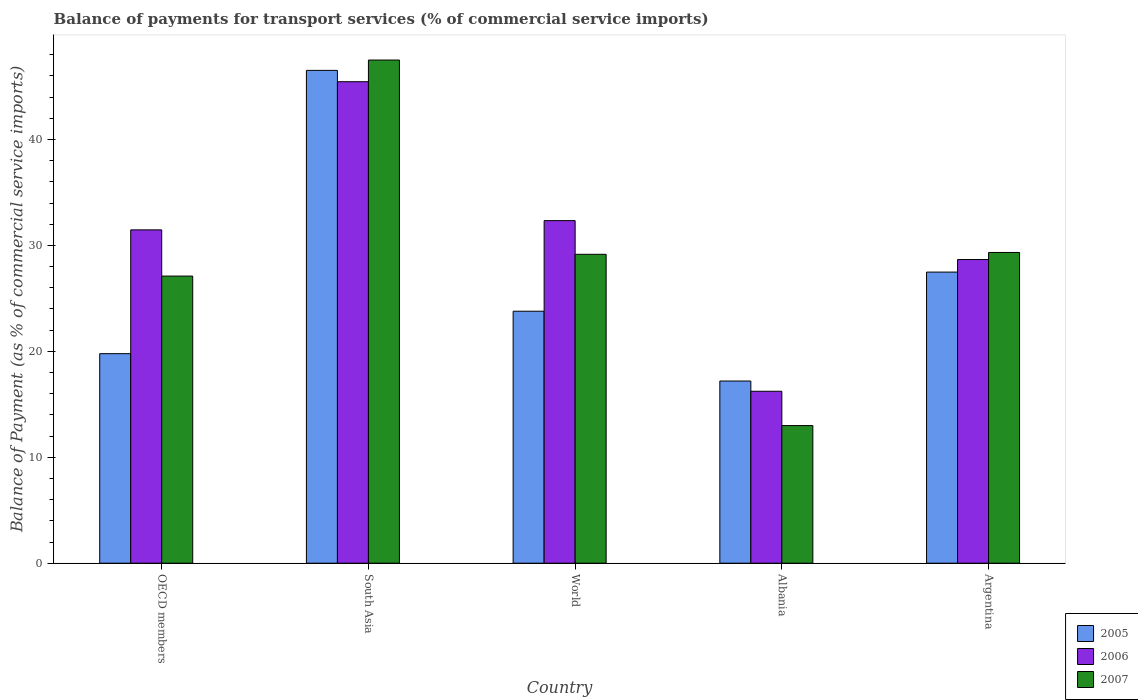How many groups of bars are there?
Your response must be concise. 5. Are the number of bars on each tick of the X-axis equal?
Your answer should be compact. Yes. What is the label of the 4th group of bars from the left?
Ensure brevity in your answer.  Albania. What is the balance of payments for transport services in 2005 in World?
Give a very brief answer. 23.79. Across all countries, what is the maximum balance of payments for transport services in 2007?
Offer a terse response. 47.5. Across all countries, what is the minimum balance of payments for transport services in 2005?
Keep it short and to the point. 17.2. In which country was the balance of payments for transport services in 2007 maximum?
Offer a terse response. South Asia. In which country was the balance of payments for transport services in 2007 minimum?
Your answer should be compact. Albania. What is the total balance of payments for transport services in 2006 in the graph?
Your answer should be very brief. 154.16. What is the difference between the balance of payments for transport services in 2005 in OECD members and that in World?
Keep it short and to the point. -4.01. What is the difference between the balance of payments for transport services in 2005 in OECD members and the balance of payments for transport services in 2006 in Argentina?
Your response must be concise. -8.88. What is the average balance of payments for transport services in 2006 per country?
Provide a succinct answer. 30.83. What is the difference between the balance of payments for transport services of/in 2007 and balance of payments for transport services of/in 2005 in South Asia?
Keep it short and to the point. 0.98. What is the ratio of the balance of payments for transport services in 2007 in Albania to that in OECD members?
Provide a succinct answer. 0.48. Is the balance of payments for transport services in 2006 in OECD members less than that in South Asia?
Your answer should be very brief. Yes. Is the difference between the balance of payments for transport services in 2007 in Albania and World greater than the difference between the balance of payments for transport services in 2005 in Albania and World?
Provide a short and direct response. No. What is the difference between the highest and the second highest balance of payments for transport services in 2005?
Give a very brief answer. -19.04. What is the difference between the highest and the lowest balance of payments for transport services in 2007?
Provide a short and direct response. 34.51. Is the sum of the balance of payments for transport services in 2006 in OECD members and South Asia greater than the maximum balance of payments for transport services in 2005 across all countries?
Your answer should be very brief. Yes. How many bars are there?
Your response must be concise. 15. What is the difference between two consecutive major ticks on the Y-axis?
Offer a very short reply. 10. How are the legend labels stacked?
Your response must be concise. Vertical. What is the title of the graph?
Make the answer very short. Balance of payments for transport services (% of commercial service imports). Does "2014" appear as one of the legend labels in the graph?
Offer a terse response. No. What is the label or title of the X-axis?
Offer a terse response. Country. What is the label or title of the Y-axis?
Offer a very short reply. Balance of Payment (as % of commercial service imports). What is the Balance of Payment (as % of commercial service imports) of 2005 in OECD members?
Make the answer very short. 19.78. What is the Balance of Payment (as % of commercial service imports) in 2006 in OECD members?
Your response must be concise. 31.47. What is the Balance of Payment (as % of commercial service imports) in 2007 in OECD members?
Ensure brevity in your answer.  27.11. What is the Balance of Payment (as % of commercial service imports) of 2005 in South Asia?
Give a very brief answer. 46.53. What is the Balance of Payment (as % of commercial service imports) in 2006 in South Asia?
Provide a succinct answer. 45.46. What is the Balance of Payment (as % of commercial service imports) in 2007 in South Asia?
Your answer should be compact. 47.5. What is the Balance of Payment (as % of commercial service imports) of 2005 in World?
Provide a succinct answer. 23.79. What is the Balance of Payment (as % of commercial service imports) of 2006 in World?
Offer a very short reply. 32.34. What is the Balance of Payment (as % of commercial service imports) of 2007 in World?
Your answer should be very brief. 29.16. What is the Balance of Payment (as % of commercial service imports) of 2005 in Albania?
Offer a terse response. 17.2. What is the Balance of Payment (as % of commercial service imports) of 2006 in Albania?
Your answer should be compact. 16.23. What is the Balance of Payment (as % of commercial service imports) of 2007 in Albania?
Offer a terse response. 12.99. What is the Balance of Payment (as % of commercial service imports) in 2005 in Argentina?
Offer a terse response. 27.48. What is the Balance of Payment (as % of commercial service imports) in 2006 in Argentina?
Keep it short and to the point. 28.67. What is the Balance of Payment (as % of commercial service imports) of 2007 in Argentina?
Your answer should be compact. 29.34. Across all countries, what is the maximum Balance of Payment (as % of commercial service imports) of 2005?
Offer a very short reply. 46.53. Across all countries, what is the maximum Balance of Payment (as % of commercial service imports) of 2006?
Your answer should be compact. 45.46. Across all countries, what is the maximum Balance of Payment (as % of commercial service imports) in 2007?
Ensure brevity in your answer.  47.5. Across all countries, what is the minimum Balance of Payment (as % of commercial service imports) in 2005?
Your response must be concise. 17.2. Across all countries, what is the minimum Balance of Payment (as % of commercial service imports) of 2006?
Offer a terse response. 16.23. Across all countries, what is the minimum Balance of Payment (as % of commercial service imports) of 2007?
Provide a short and direct response. 12.99. What is the total Balance of Payment (as % of commercial service imports) in 2005 in the graph?
Offer a terse response. 134.78. What is the total Balance of Payment (as % of commercial service imports) of 2006 in the graph?
Your answer should be compact. 154.16. What is the total Balance of Payment (as % of commercial service imports) of 2007 in the graph?
Provide a short and direct response. 146.1. What is the difference between the Balance of Payment (as % of commercial service imports) in 2005 in OECD members and that in South Asia?
Make the answer very short. -26.74. What is the difference between the Balance of Payment (as % of commercial service imports) in 2006 in OECD members and that in South Asia?
Offer a terse response. -13.99. What is the difference between the Balance of Payment (as % of commercial service imports) in 2007 in OECD members and that in South Asia?
Your answer should be very brief. -20.39. What is the difference between the Balance of Payment (as % of commercial service imports) in 2005 in OECD members and that in World?
Your response must be concise. -4.01. What is the difference between the Balance of Payment (as % of commercial service imports) in 2006 in OECD members and that in World?
Your answer should be compact. -0.87. What is the difference between the Balance of Payment (as % of commercial service imports) in 2007 in OECD members and that in World?
Provide a short and direct response. -2.05. What is the difference between the Balance of Payment (as % of commercial service imports) of 2005 in OECD members and that in Albania?
Give a very brief answer. 2.58. What is the difference between the Balance of Payment (as % of commercial service imports) of 2006 in OECD members and that in Albania?
Keep it short and to the point. 15.24. What is the difference between the Balance of Payment (as % of commercial service imports) of 2007 in OECD members and that in Albania?
Give a very brief answer. 14.11. What is the difference between the Balance of Payment (as % of commercial service imports) of 2005 in OECD members and that in Argentina?
Provide a short and direct response. -7.7. What is the difference between the Balance of Payment (as % of commercial service imports) of 2006 in OECD members and that in Argentina?
Provide a short and direct response. 2.8. What is the difference between the Balance of Payment (as % of commercial service imports) in 2007 in OECD members and that in Argentina?
Provide a succinct answer. -2.23. What is the difference between the Balance of Payment (as % of commercial service imports) in 2005 in South Asia and that in World?
Your response must be concise. 22.74. What is the difference between the Balance of Payment (as % of commercial service imports) of 2006 in South Asia and that in World?
Your answer should be compact. 13.12. What is the difference between the Balance of Payment (as % of commercial service imports) in 2007 in South Asia and that in World?
Offer a terse response. 18.34. What is the difference between the Balance of Payment (as % of commercial service imports) of 2005 in South Asia and that in Albania?
Offer a terse response. 29.33. What is the difference between the Balance of Payment (as % of commercial service imports) of 2006 in South Asia and that in Albania?
Keep it short and to the point. 29.22. What is the difference between the Balance of Payment (as % of commercial service imports) of 2007 in South Asia and that in Albania?
Your answer should be very brief. 34.51. What is the difference between the Balance of Payment (as % of commercial service imports) in 2005 in South Asia and that in Argentina?
Offer a very short reply. 19.04. What is the difference between the Balance of Payment (as % of commercial service imports) of 2006 in South Asia and that in Argentina?
Your answer should be compact. 16.79. What is the difference between the Balance of Payment (as % of commercial service imports) of 2007 in South Asia and that in Argentina?
Make the answer very short. 18.17. What is the difference between the Balance of Payment (as % of commercial service imports) of 2005 in World and that in Albania?
Give a very brief answer. 6.59. What is the difference between the Balance of Payment (as % of commercial service imports) of 2006 in World and that in Albania?
Your answer should be compact. 16.11. What is the difference between the Balance of Payment (as % of commercial service imports) of 2007 in World and that in Albania?
Your response must be concise. 16.17. What is the difference between the Balance of Payment (as % of commercial service imports) of 2005 in World and that in Argentina?
Offer a terse response. -3.69. What is the difference between the Balance of Payment (as % of commercial service imports) in 2006 in World and that in Argentina?
Make the answer very short. 3.67. What is the difference between the Balance of Payment (as % of commercial service imports) of 2007 in World and that in Argentina?
Provide a succinct answer. -0.17. What is the difference between the Balance of Payment (as % of commercial service imports) in 2005 in Albania and that in Argentina?
Your response must be concise. -10.29. What is the difference between the Balance of Payment (as % of commercial service imports) in 2006 in Albania and that in Argentina?
Make the answer very short. -12.43. What is the difference between the Balance of Payment (as % of commercial service imports) of 2007 in Albania and that in Argentina?
Give a very brief answer. -16.34. What is the difference between the Balance of Payment (as % of commercial service imports) in 2005 in OECD members and the Balance of Payment (as % of commercial service imports) in 2006 in South Asia?
Offer a terse response. -25.67. What is the difference between the Balance of Payment (as % of commercial service imports) in 2005 in OECD members and the Balance of Payment (as % of commercial service imports) in 2007 in South Asia?
Your answer should be compact. -27.72. What is the difference between the Balance of Payment (as % of commercial service imports) of 2006 in OECD members and the Balance of Payment (as % of commercial service imports) of 2007 in South Asia?
Your answer should be very brief. -16.03. What is the difference between the Balance of Payment (as % of commercial service imports) of 2005 in OECD members and the Balance of Payment (as % of commercial service imports) of 2006 in World?
Keep it short and to the point. -12.56. What is the difference between the Balance of Payment (as % of commercial service imports) of 2005 in OECD members and the Balance of Payment (as % of commercial service imports) of 2007 in World?
Provide a short and direct response. -9.38. What is the difference between the Balance of Payment (as % of commercial service imports) in 2006 in OECD members and the Balance of Payment (as % of commercial service imports) in 2007 in World?
Make the answer very short. 2.31. What is the difference between the Balance of Payment (as % of commercial service imports) in 2005 in OECD members and the Balance of Payment (as % of commercial service imports) in 2006 in Albania?
Your response must be concise. 3.55. What is the difference between the Balance of Payment (as % of commercial service imports) in 2005 in OECD members and the Balance of Payment (as % of commercial service imports) in 2007 in Albania?
Give a very brief answer. 6.79. What is the difference between the Balance of Payment (as % of commercial service imports) in 2006 in OECD members and the Balance of Payment (as % of commercial service imports) in 2007 in Albania?
Ensure brevity in your answer.  18.48. What is the difference between the Balance of Payment (as % of commercial service imports) in 2005 in OECD members and the Balance of Payment (as % of commercial service imports) in 2006 in Argentina?
Give a very brief answer. -8.88. What is the difference between the Balance of Payment (as % of commercial service imports) in 2005 in OECD members and the Balance of Payment (as % of commercial service imports) in 2007 in Argentina?
Offer a very short reply. -9.55. What is the difference between the Balance of Payment (as % of commercial service imports) of 2006 in OECD members and the Balance of Payment (as % of commercial service imports) of 2007 in Argentina?
Offer a terse response. 2.13. What is the difference between the Balance of Payment (as % of commercial service imports) of 2005 in South Asia and the Balance of Payment (as % of commercial service imports) of 2006 in World?
Offer a very short reply. 14.19. What is the difference between the Balance of Payment (as % of commercial service imports) in 2005 in South Asia and the Balance of Payment (as % of commercial service imports) in 2007 in World?
Your answer should be compact. 17.36. What is the difference between the Balance of Payment (as % of commercial service imports) in 2006 in South Asia and the Balance of Payment (as % of commercial service imports) in 2007 in World?
Provide a succinct answer. 16.29. What is the difference between the Balance of Payment (as % of commercial service imports) in 2005 in South Asia and the Balance of Payment (as % of commercial service imports) in 2006 in Albania?
Give a very brief answer. 30.29. What is the difference between the Balance of Payment (as % of commercial service imports) in 2005 in South Asia and the Balance of Payment (as % of commercial service imports) in 2007 in Albania?
Keep it short and to the point. 33.53. What is the difference between the Balance of Payment (as % of commercial service imports) of 2006 in South Asia and the Balance of Payment (as % of commercial service imports) of 2007 in Albania?
Provide a short and direct response. 32.46. What is the difference between the Balance of Payment (as % of commercial service imports) of 2005 in South Asia and the Balance of Payment (as % of commercial service imports) of 2006 in Argentina?
Your answer should be compact. 17.86. What is the difference between the Balance of Payment (as % of commercial service imports) in 2005 in South Asia and the Balance of Payment (as % of commercial service imports) in 2007 in Argentina?
Make the answer very short. 17.19. What is the difference between the Balance of Payment (as % of commercial service imports) in 2006 in South Asia and the Balance of Payment (as % of commercial service imports) in 2007 in Argentina?
Ensure brevity in your answer.  16.12. What is the difference between the Balance of Payment (as % of commercial service imports) in 2005 in World and the Balance of Payment (as % of commercial service imports) in 2006 in Albania?
Your response must be concise. 7.56. What is the difference between the Balance of Payment (as % of commercial service imports) in 2005 in World and the Balance of Payment (as % of commercial service imports) in 2007 in Albania?
Provide a succinct answer. 10.8. What is the difference between the Balance of Payment (as % of commercial service imports) in 2006 in World and the Balance of Payment (as % of commercial service imports) in 2007 in Albania?
Your answer should be compact. 19.35. What is the difference between the Balance of Payment (as % of commercial service imports) of 2005 in World and the Balance of Payment (as % of commercial service imports) of 2006 in Argentina?
Keep it short and to the point. -4.88. What is the difference between the Balance of Payment (as % of commercial service imports) of 2005 in World and the Balance of Payment (as % of commercial service imports) of 2007 in Argentina?
Ensure brevity in your answer.  -5.55. What is the difference between the Balance of Payment (as % of commercial service imports) of 2006 in World and the Balance of Payment (as % of commercial service imports) of 2007 in Argentina?
Offer a very short reply. 3. What is the difference between the Balance of Payment (as % of commercial service imports) of 2005 in Albania and the Balance of Payment (as % of commercial service imports) of 2006 in Argentina?
Give a very brief answer. -11.47. What is the difference between the Balance of Payment (as % of commercial service imports) in 2005 in Albania and the Balance of Payment (as % of commercial service imports) in 2007 in Argentina?
Your response must be concise. -12.14. What is the difference between the Balance of Payment (as % of commercial service imports) of 2006 in Albania and the Balance of Payment (as % of commercial service imports) of 2007 in Argentina?
Offer a terse response. -13.1. What is the average Balance of Payment (as % of commercial service imports) in 2005 per country?
Ensure brevity in your answer.  26.96. What is the average Balance of Payment (as % of commercial service imports) in 2006 per country?
Offer a terse response. 30.83. What is the average Balance of Payment (as % of commercial service imports) in 2007 per country?
Offer a terse response. 29.22. What is the difference between the Balance of Payment (as % of commercial service imports) in 2005 and Balance of Payment (as % of commercial service imports) in 2006 in OECD members?
Make the answer very short. -11.69. What is the difference between the Balance of Payment (as % of commercial service imports) in 2005 and Balance of Payment (as % of commercial service imports) in 2007 in OECD members?
Your answer should be very brief. -7.33. What is the difference between the Balance of Payment (as % of commercial service imports) of 2006 and Balance of Payment (as % of commercial service imports) of 2007 in OECD members?
Provide a short and direct response. 4.36. What is the difference between the Balance of Payment (as % of commercial service imports) in 2005 and Balance of Payment (as % of commercial service imports) in 2006 in South Asia?
Your response must be concise. 1.07. What is the difference between the Balance of Payment (as % of commercial service imports) in 2005 and Balance of Payment (as % of commercial service imports) in 2007 in South Asia?
Provide a short and direct response. -0.98. What is the difference between the Balance of Payment (as % of commercial service imports) of 2006 and Balance of Payment (as % of commercial service imports) of 2007 in South Asia?
Your response must be concise. -2.05. What is the difference between the Balance of Payment (as % of commercial service imports) in 2005 and Balance of Payment (as % of commercial service imports) in 2006 in World?
Offer a very short reply. -8.55. What is the difference between the Balance of Payment (as % of commercial service imports) in 2005 and Balance of Payment (as % of commercial service imports) in 2007 in World?
Provide a succinct answer. -5.37. What is the difference between the Balance of Payment (as % of commercial service imports) of 2006 and Balance of Payment (as % of commercial service imports) of 2007 in World?
Your answer should be compact. 3.18. What is the difference between the Balance of Payment (as % of commercial service imports) in 2005 and Balance of Payment (as % of commercial service imports) in 2006 in Albania?
Keep it short and to the point. 0.97. What is the difference between the Balance of Payment (as % of commercial service imports) in 2005 and Balance of Payment (as % of commercial service imports) in 2007 in Albania?
Provide a succinct answer. 4.2. What is the difference between the Balance of Payment (as % of commercial service imports) in 2006 and Balance of Payment (as % of commercial service imports) in 2007 in Albania?
Your response must be concise. 3.24. What is the difference between the Balance of Payment (as % of commercial service imports) in 2005 and Balance of Payment (as % of commercial service imports) in 2006 in Argentina?
Offer a terse response. -1.18. What is the difference between the Balance of Payment (as % of commercial service imports) of 2005 and Balance of Payment (as % of commercial service imports) of 2007 in Argentina?
Your response must be concise. -1.85. What is the difference between the Balance of Payment (as % of commercial service imports) of 2006 and Balance of Payment (as % of commercial service imports) of 2007 in Argentina?
Offer a very short reply. -0.67. What is the ratio of the Balance of Payment (as % of commercial service imports) of 2005 in OECD members to that in South Asia?
Give a very brief answer. 0.43. What is the ratio of the Balance of Payment (as % of commercial service imports) in 2006 in OECD members to that in South Asia?
Ensure brevity in your answer.  0.69. What is the ratio of the Balance of Payment (as % of commercial service imports) in 2007 in OECD members to that in South Asia?
Make the answer very short. 0.57. What is the ratio of the Balance of Payment (as % of commercial service imports) in 2005 in OECD members to that in World?
Provide a succinct answer. 0.83. What is the ratio of the Balance of Payment (as % of commercial service imports) of 2006 in OECD members to that in World?
Offer a very short reply. 0.97. What is the ratio of the Balance of Payment (as % of commercial service imports) in 2007 in OECD members to that in World?
Provide a short and direct response. 0.93. What is the ratio of the Balance of Payment (as % of commercial service imports) in 2005 in OECD members to that in Albania?
Your answer should be very brief. 1.15. What is the ratio of the Balance of Payment (as % of commercial service imports) of 2006 in OECD members to that in Albania?
Give a very brief answer. 1.94. What is the ratio of the Balance of Payment (as % of commercial service imports) of 2007 in OECD members to that in Albania?
Your response must be concise. 2.09. What is the ratio of the Balance of Payment (as % of commercial service imports) of 2005 in OECD members to that in Argentina?
Give a very brief answer. 0.72. What is the ratio of the Balance of Payment (as % of commercial service imports) of 2006 in OECD members to that in Argentina?
Offer a very short reply. 1.1. What is the ratio of the Balance of Payment (as % of commercial service imports) of 2007 in OECD members to that in Argentina?
Offer a terse response. 0.92. What is the ratio of the Balance of Payment (as % of commercial service imports) in 2005 in South Asia to that in World?
Your answer should be very brief. 1.96. What is the ratio of the Balance of Payment (as % of commercial service imports) in 2006 in South Asia to that in World?
Keep it short and to the point. 1.41. What is the ratio of the Balance of Payment (as % of commercial service imports) in 2007 in South Asia to that in World?
Keep it short and to the point. 1.63. What is the ratio of the Balance of Payment (as % of commercial service imports) in 2005 in South Asia to that in Albania?
Offer a terse response. 2.71. What is the ratio of the Balance of Payment (as % of commercial service imports) in 2006 in South Asia to that in Albania?
Your answer should be very brief. 2.8. What is the ratio of the Balance of Payment (as % of commercial service imports) of 2007 in South Asia to that in Albania?
Your answer should be compact. 3.66. What is the ratio of the Balance of Payment (as % of commercial service imports) in 2005 in South Asia to that in Argentina?
Offer a very short reply. 1.69. What is the ratio of the Balance of Payment (as % of commercial service imports) of 2006 in South Asia to that in Argentina?
Your answer should be compact. 1.59. What is the ratio of the Balance of Payment (as % of commercial service imports) of 2007 in South Asia to that in Argentina?
Ensure brevity in your answer.  1.62. What is the ratio of the Balance of Payment (as % of commercial service imports) in 2005 in World to that in Albania?
Provide a succinct answer. 1.38. What is the ratio of the Balance of Payment (as % of commercial service imports) of 2006 in World to that in Albania?
Your answer should be compact. 1.99. What is the ratio of the Balance of Payment (as % of commercial service imports) in 2007 in World to that in Albania?
Provide a succinct answer. 2.24. What is the ratio of the Balance of Payment (as % of commercial service imports) in 2005 in World to that in Argentina?
Offer a terse response. 0.87. What is the ratio of the Balance of Payment (as % of commercial service imports) of 2006 in World to that in Argentina?
Keep it short and to the point. 1.13. What is the ratio of the Balance of Payment (as % of commercial service imports) of 2005 in Albania to that in Argentina?
Ensure brevity in your answer.  0.63. What is the ratio of the Balance of Payment (as % of commercial service imports) in 2006 in Albania to that in Argentina?
Ensure brevity in your answer.  0.57. What is the ratio of the Balance of Payment (as % of commercial service imports) in 2007 in Albania to that in Argentina?
Offer a terse response. 0.44. What is the difference between the highest and the second highest Balance of Payment (as % of commercial service imports) of 2005?
Give a very brief answer. 19.04. What is the difference between the highest and the second highest Balance of Payment (as % of commercial service imports) in 2006?
Offer a terse response. 13.12. What is the difference between the highest and the second highest Balance of Payment (as % of commercial service imports) in 2007?
Provide a short and direct response. 18.17. What is the difference between the highest and the lowest Balance of Payment (as % of commercial service imports) of 2005?
Ensure brevity in your answer.  29.33. What is the difference between the highest and the lowest Balance of Payment (as % of commercial service imports) of 2006?
Ensure brevity in your answer.  29.22. What is the difference between the highest and the lowest Balance of Payment (as % of commercial service imports) in 2007?
Give a very brief answer. 34.51. 